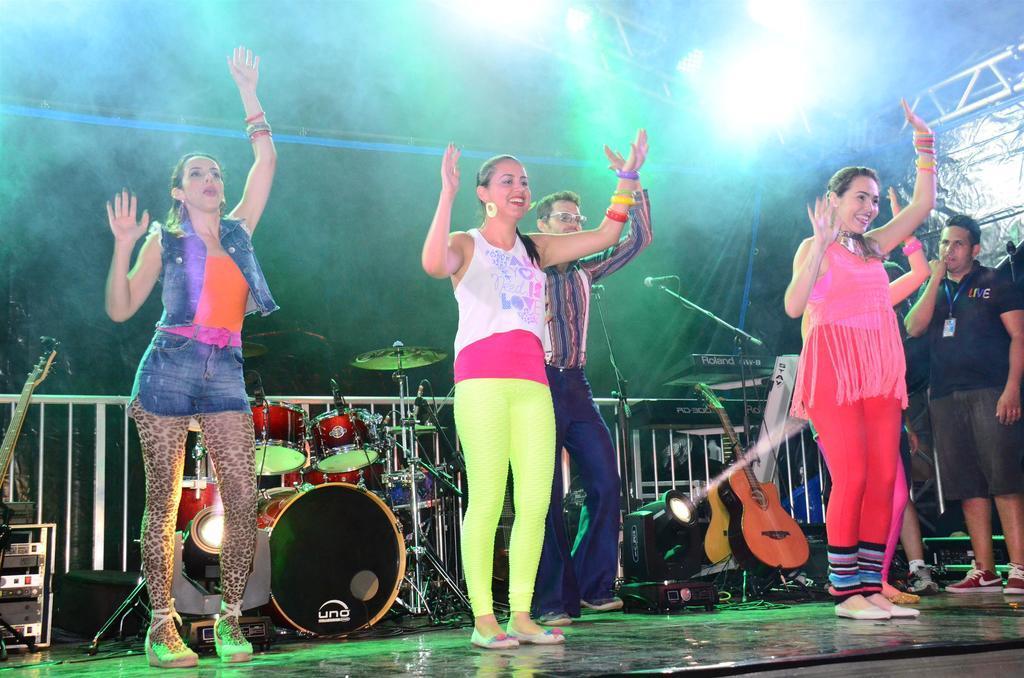Could you give a brief overview of what you see in this image? In the picture we can see some women and a man are standing and dancing on the floor and behind them, we can see some orchestral instruments and some guitars are placed on the floor and we can also see a focus light on the floor and to the ceiling we can see some focus lights to the stand. 